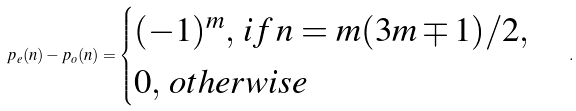Convert formula to latex. <formula><loc_0><loc_0><loc_500><loc_500>p _ { e } ( n ) - p _ { o } ( n ) = \begin{cases} ( - 1 ) ^ { m } , \, i f \, n = m ( 3 m \mp 1 ) / 2 , \\ 0 , \, o t h e r w i s e \end{cases} .</formula> 